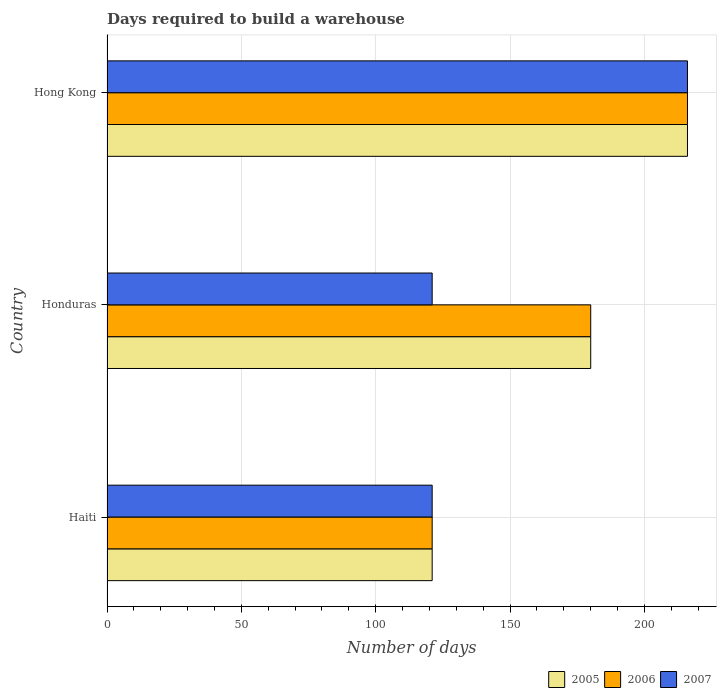How many different coloured bars are there?
Your answer should be very brief. 3. How many bars are there on the 2nd tick from the bottom?
Provide a succinct answer. 3. What is the label of the 1st group of bars from the top?
Your answer should be compact. Hong Kong. What is the days required to build a warehouse in in 2007 in Honduras?
Your response must be concise. 121. Across all countries, what is the maximum days required to build a warehouse in in 2005?
Your answer should be very brief. 216. Across all countries, what is the minimum days required to build a warehouse in in 2005?
Your response must be concise. 121. In which country was the days required to build a warehouse in in 2007 maximum?
Your response must be concise. Hong Kong. In which country was the days required to build a warehouse in in 2007 minimum?
Your answer should be compact. Haiti. What is the total days required to build a warehouse in in 2007 in the graph?
Give a very brief answer. 458. What is the difference between the days required to build a warehouse in in 2005 in Haiti and that in Honduras?
Your response must be concise. -59. What is the difference between the days required to build a warehouse in in 2006 in Honduras and the days required to build a warehouse in in 2005 in Hong Kong?
Provide a succinct answer. -36. What is the average days required to build a warehouse in in 2007 per country?
Ensure brevity in your answer.  152.67. What is the difference between the days required to build a warehouse in in 2006 and days required to build a warehouse in in 2007 in Honduras?
Give a very brief answer. 59. In how many countries, is the days required to build a warehouse in in 2005 greater than 90 days?
Make the answer very short. 3. What is the ratio of the days required to build a warehouse in in 2005 in Honduras to that in Hong Kong?
Provide a short and direct response. 0.83. What is the difference between the highest and the second highest days required to build a warehouse in in 2007?
Ensure brevity in your answer.  95. In how many countries, is the days required to build a warehouse in in 2006 greater than the average days required to build a warehouse in in 2006 taken over all countries?
Keep it short and to the point. 2. Is the sum of the days required to build a warehouse in in 2005 in Honduras and Hong Kong greater than the maximum days required to build a warehouse in in 2007 across all countries?
Provide a short and direct response. Yes. What does the 3rd bar from the top in Honduras represents?
Offer a terse response. 2005. What does the 2nd bar from the bottom in Haiti represents?
Ensure brevity in your answer.  2006. How many countries are there in the graph?
Give a very brief answer. 3. Does the graph contain any zero values?
Your response must be concise. No. Does the graph contain grids?
Offer a terse response. Yes. Where does the legend appear in the graph?
Your response must be concise. Bottom right. How many legend labels are there?
Provide a short and direct response. 3. What is the title of the graph?
Ensure brevity in your answer.  Days required to build a warehouse. Does "1961" appear as one of the legend labels in the graph?
Your response must be concise. No. What is the label or title of the X-axis?
Keep it short and to the point. Number of days. What is the Number of days in 2005 in Haiti?
Offer a very short reply. 121. What is the Number of days of 2006 in Haiti?
Offer a very short reply. 121. What is the Number of days of 2007 in Haiti?
Provide a short and direct response. 121. What is the Number of days in 2005 in Honduras?
Your answer should be very brief. 180. What is the Number of days of 2006 in Honduras?
Offer a very short reply. 180. What is the Number of days in 2007 in Honduras?
Ensure brevity in your answer.  121. What is the Number of days of 2005 in Hong Kong?
Ensure brevity in your answer.  216. What is the Number of days in 2006 in Hong Kong?
Keep it short and to the point. 216. What is the Number of days in 2007 in Hong Kong?
Make the answer very short. 216. Across all countries, what is the maximum Number of days of 2005?
Provide a succinct answer. 216. Across all countries, what is the maximum Number of days in 2006?
Give a very brief answer. 216. Across all countries, what is the maximum Number of days of 2007?
Give a very brief answer. 216. Across all countries, what is the minimum Number of days of 2005?
Provide a short and direct response. 121. Across all countries, what is the minimum Number of days of 2006?
Give a very brief answer. 121. Across all countries, what is the minimum Number of days in 2007?
Give a very brief answer. 121. What is the total Number of days of 2005 in the graph?
Provide a short and direct response. 517. What is the total Number of days of 2006 in the graph?
Offer a terse response. 517. What is the total Number of days in 2007 in the graph?
Your answer should be compact. 458. What is the difference between the Number of days of 2005 in Haiti and that in Honduras?
Your answer should be very brief. -59. What is the difference between the Number of days of 2006 in Haiti and that in Honduras?
Give a very brief answer. -59. What is the difference between the Number of days in 2005 in Haiti and that in Hong Kong?
Make the answer very short. -95. What is the difference between the Number of days of 2006 in Haiti and that in Hong Kong?
Make the answer very short. -95. What is the difference between the Number of days of 2007 in Haiti and that in Hong Kong?
Make the answer very short. -95. What is the difference between the Number of days of 2005 in Honduras and that in Hong Kong?
Your answer should be compact. -36. What is the difference between the Number of days in 2006 in Honduras and that in Hong Kong?
Your response must be concise. -36. What is the difference between the Number of days of 2007 in Honduras and that in Hong Kong?
Your response must be concise. -95. What is the difference between the Number of days of 2005 in Haiti and the Number of days of 2006 in Honduras?
Provide a succinct answer. -59. What is the difference between the Number of days of 2005 in Haiti and the Number of days of 2006 in Hong Kong?
Give a very brief answer. -95. What is the difference between the Number of days in 2005 in Haiti and the Number of days in 2007 in Hong Kong?
Keep it short and to the point. -95. What is the difference between the Number of days of 2006 in Haiti and the Number of days of 2007 in Hong Kong?
Give a very brief answer. -95. What is the difference between the Number of days in 2005 in Honduras and the Number of days in 2006 in Hong Kong?
Keep it short and to the point. -36. What is the difference between the Number of days of 2005 in Honduras and the Number of days of 2007 in Hong Kong?
Your answer should be compact. -36. What is the difference between the Number of days of 2006 in Honduras and the Number of days of 2007 in Hong Kong?
Provide a succinct answer. -36. What is the average Number of days of 2005 per country?
Ensure brevity in your answer.  172.33. What is the average Number of days of 2006 per country?
Keep it short and to the point. 172.33. What is the average Number of days in 2007 per country?
Provide a short and direct response. 152.67. What is the difference between the Number of days of 2006 and Number of days of 2007 in Honduras?
Provide a succinct answer. 59. What is the difference between the Number of days in 2005 and Number of days in 2006 in Hong Kong?
Offer a very short reply. 0. What is the difference between the Number of days in 2005 and Number of days in 2007 in Hong Kong?
Ensure brevity in your answer.  0. What is the difference between the Number of days of 2006 and Number of days of 2007 in Hong Kong?
Provide a short and direct response. 0. What is the ratio of the Number of days in 2005 in Haiti to that in Honduras?
Offer a very short reply. 0.67. What is the ratio of the Number of days in 2006 in Haiti to that in Honduras?
Ensure brevity in your answer.  0.67. What is the ratio of the Number of days of 2007 in Haiti to that in Honduras?
Your answer should be compact. 1. What is the ratio of the Number of days of 2005 in Haiti to that in Hong Kong?
Ensure brevity in your answer.  0.56. What is the ratio of the Number of days of 2006 in Haiti to that in Hong Kong?
Provide a succinct answer. 0.56. What is the ratio of the Number of days of 2007 in Haiti to that in Hong Kong?
Make the answer very short. 0.56. What is the ratio of the Number of days in 2006 in Honduras to that in Hong Kong?
Provide a succinct answer. 0.83. What is the ratio of the Number of days in 2007 in Honduras to that in Hong Kong?
Offer a very short reply. 0.56. What is the difference between the highest and the second highest Number of days of 2006?
Offer a terse response. 36. What is the difference between the highest and the second highest Number of days in 2007?
Keep it short and to the point. 95. What is the difference between the highest and the lowest Number of days of 2005?
Provide a short and direct response. 95. What is the difference between the highest and the lowest Number of days in 2007?
Your response must be concise. 95. 